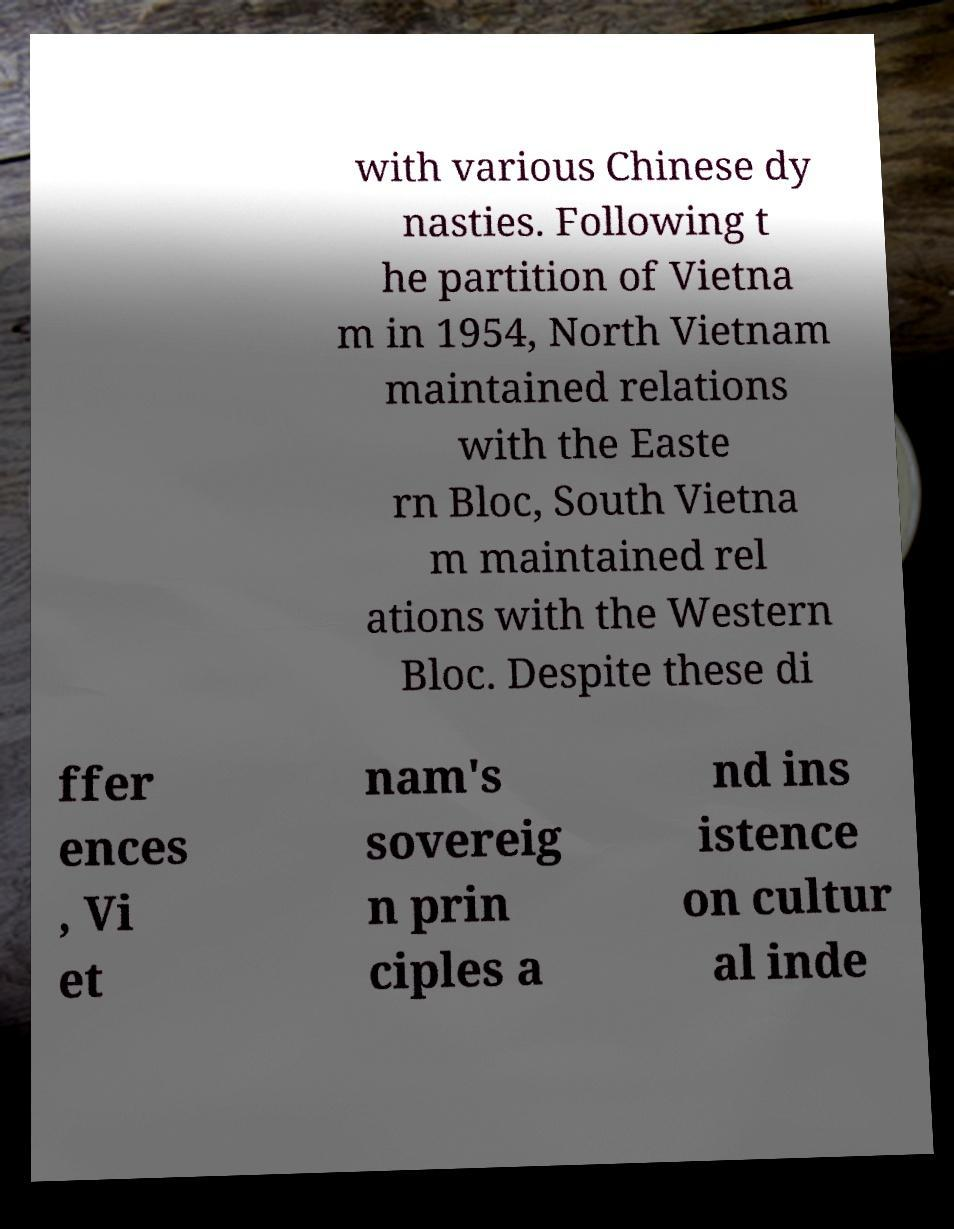Please identify and transcribe the text found in this image. with various Chinese dy nasties. Following t he partition of Vietna m in 1954, North Vietnam maintained relations with the Easte rn Bloc, South Vietna m maintained rel ations with the Western Bloc. Despite these di ffer ences , Vi et nam's sovereig n prin ciples a nd ins istence on cultur al inde 